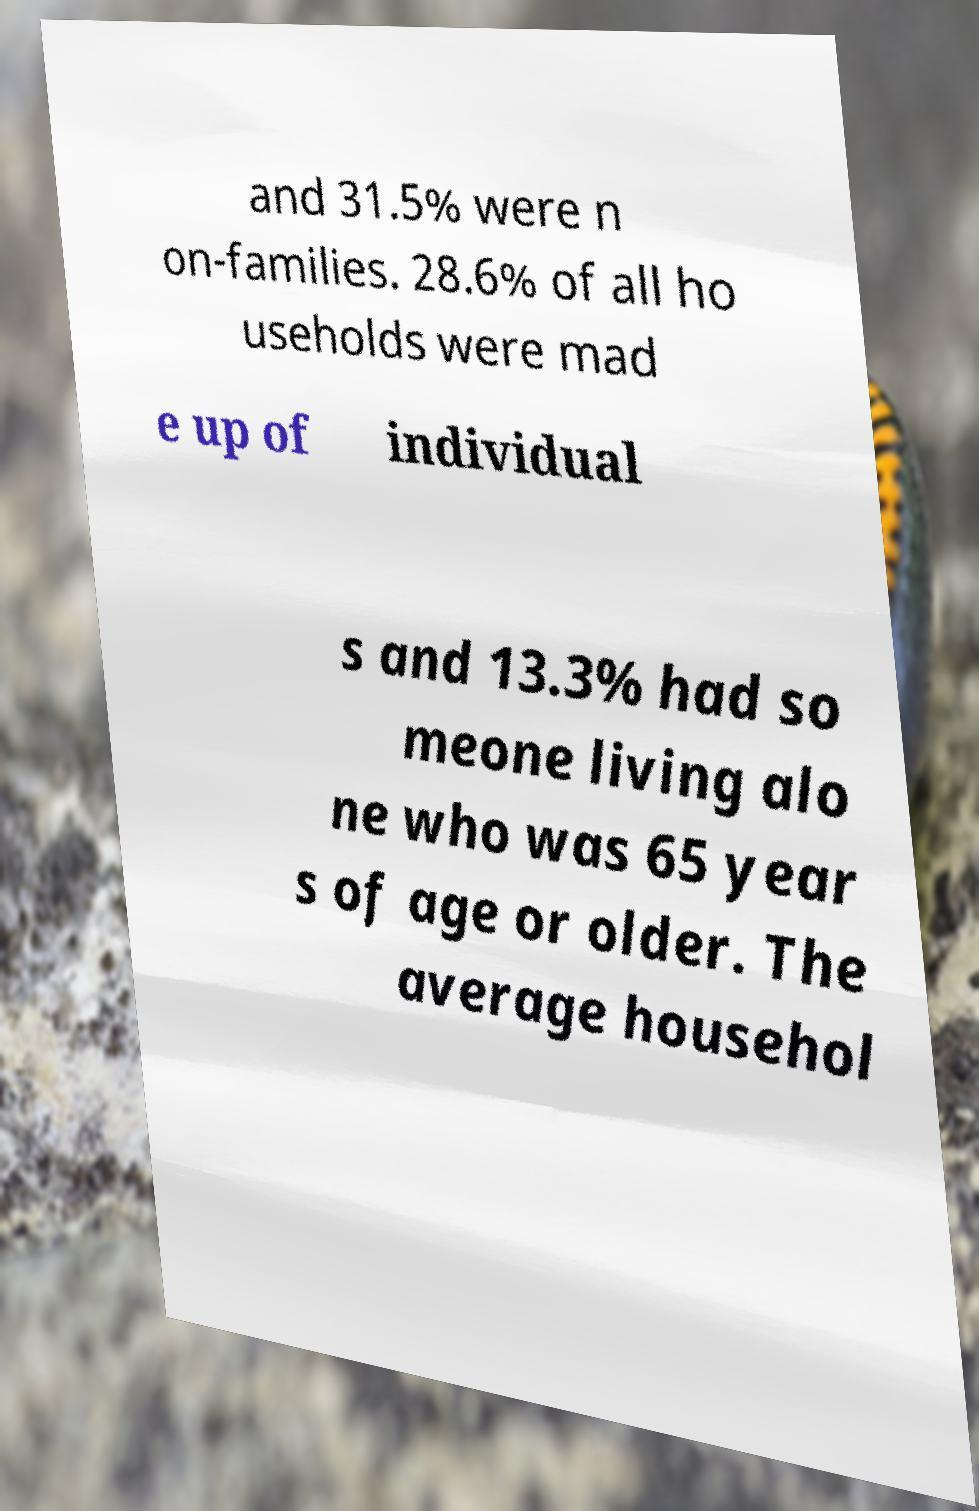What messages or text are displayed in this image? I need them in a readable, typed format. and 31.5% were n on-families. 28.6% of all ho useholds were mad e up of individual s and 13.3% had so meone living alo ne who was 65 year s of age or older. The average househol 